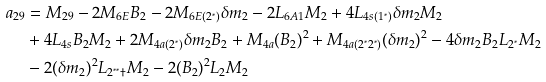Convert formula to latex. <formula><loc_0><loc_0><loc_500><loc_500>a _ { 2 9 } & = M _ { 2 9 } - 2 M _ { 6 E } B _ { 2 } - 2 M _ { 6 E ( 2 ^ { \ast } ) } \delta m _ { 2 } - 2 L _ { 6 A 1 } M _ { 2 } + 4 L _ { 4 s ( 1 ^ { \ast } ) } \delta m _ { 2 } M _ { 2 } \\ & + 4 L _ { 4 s } B _ { 2 } M _ { 2 } + 2 M _ { 4 a ( 2 ^ { \ast } ) } \delta m _ { 2 } B _ { 2 } + M _ { 4 a } ( B _ { 2 } ) ^ { 2 } + M _ { 4 a ( 2 ^ { \ast } 2 ^ { \ast } ) } ( \delta m _ { 2 } ) ^ { 2 } - 4 \delta m _ { 2 } B _ { 2 } L _ { 2 ^ { \ast } } M _ { 2 } \\ & - 2 ( \delta m _ { 2 } ) ^ { 2 } L _ { 2 ^ { \ast \ast } \dagger } M _ { 2 } - 2 ( B _ { 2 } ) ^ { 2 } L _ { 2 } M _ { 2 }</formula> 